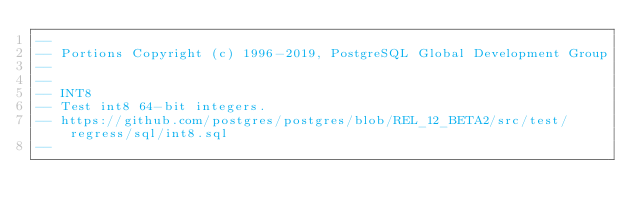<code> <loc_0><loc_0><loc_500><loc_500><_SQL_>--
-- Portions Copyright (c) 1996-2019, PostgreSQL Global Development Group
--
--
-- INT8
-- Test int8 64-bit integers.
-- https://github.com/postgres/postgres/blob/REL_12_BETA2/src/test/regress/sql/int8.sql
--</code> 